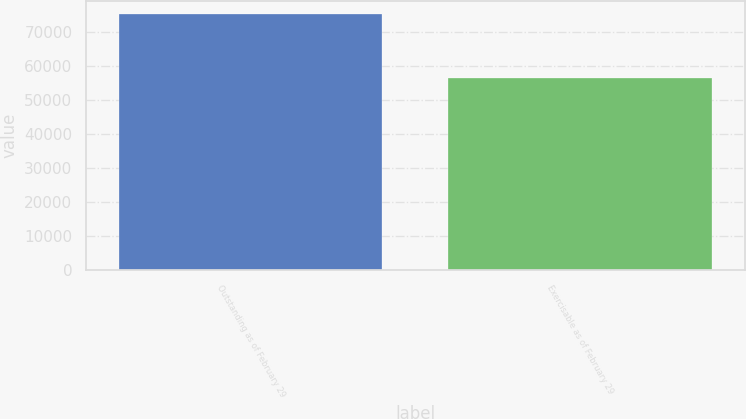<chart> <loc_0><loc_0><loc_500><loc_500><bar_chart><fcel>Outstanding as of February 29<fcel>Exercisable as of February 29<nl><fcel>75425<fcel>56475<nl></chart> 